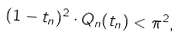Convert formula to latex. <formula><loc_0><loc_0><loc_500><loc_500>( 1 - t _ { n } ) ^ { 2 } \cdot Q _ { n } ( t _ { n } ) < \pi ^ { 2 } ,</formula> 